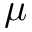<formula> <loc_0><loc_0><loc_500><loc_500>\mu</formula> 